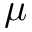<formula> <loc_0><loc_0><loc_500><loc_500>\mu</formula> 